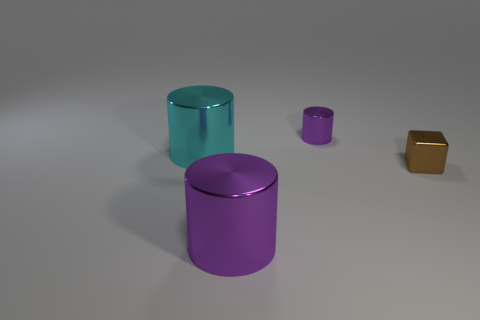Are there any big cylinders that have the same color as the shiny cube?
Ensure brevity in your answer.  No. Is the number of tiny blocks behind the large cyan metal cylinder the same as the number of brown metallic cubes?
Make the answer very short. No. Is the tiny metal block the same color as the tiny cylinder?
Keep it short and to the point. No. What size is the object that is on the left side of the brown shiny block and in front of the large cyan thing?
Give a very brief answer. Large. What color is the cube that is the same material as the small purple object?
Offer a very short reply. Brown. How many big purple spheres have the same material as the large purple thing?
Provide a succinct answer. 0. Are there the same number of shiny blocks behind the small metal block and large purple things left of the large purple metallic cylinder?
Offer a terse response. Yes. There is a big purple metal thing; does it have the same shape as the object that is behind the cyan cylinder?
Your answer should be very brief. Yes. What material is the other cylinder that is the same color as the small cylinder?
Keep it short and to the point. Metal. Are there any other things that have the same shape as the big cyan object?
Provide a succinct answer. Yes. 